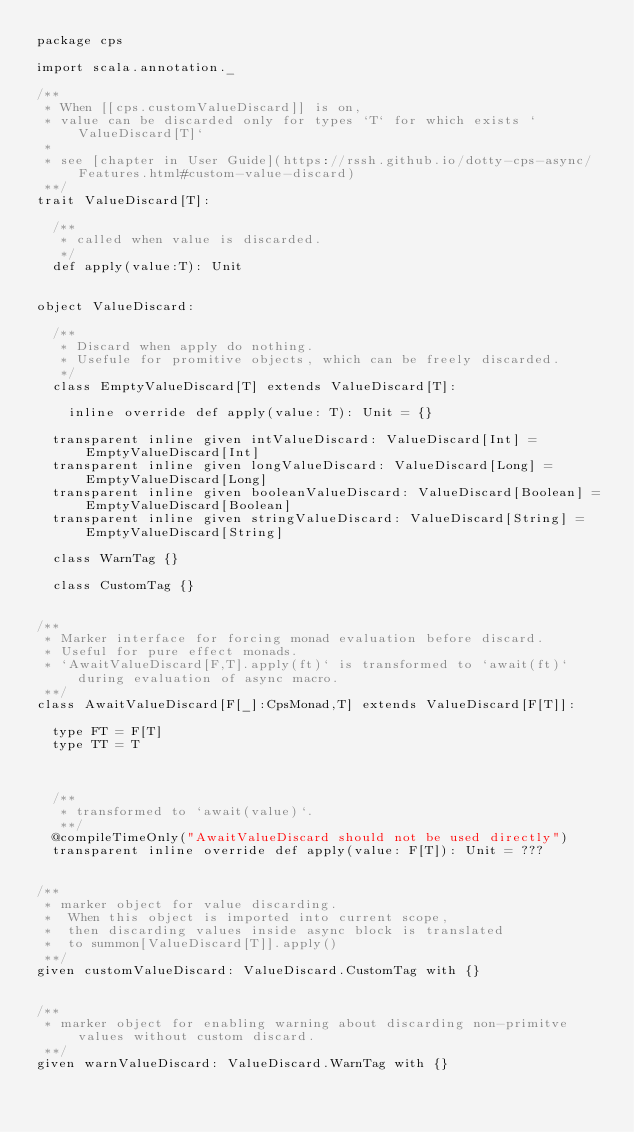Convert code to text. <code><loc_0><loc_0><loc_500><loc_500><_Scala_>package cps

import scala.annotation._

/**
 * When [[cps.customValueDiscard]] is on,
 * value can be discarded only for types `T` for which exists `ValueDiscard[T]`
 *
 * see [chapter in User Guide](https://rssh.github.io/dotty-cps-async/Features.html#custom-value-discard)
 **/
trait ValueDiscard[T]:

  /**
   * called when value is discarded. 
   */
  def apply(value:T): Unit


object ValueDiscard:

  /**
   * Discard when apply do nothing.
   * Usefule for promitive objects, which can be freely discarded.
   */
  class EmptyValueDiscard[T] extends ValueDiscard[T]:

    inline override def apply(value: T): Unit = {}

  transparent inline given intValueDiscard: ValueDiscard[Int] = EmptyValueDiscard[Int]
  transparent inline given longValueDiscard: ValueDiscard[Long] = EmptyValueDiscard[Long]
  transparent inline given booleanValueDiscard: ValueDiscard[Boolean] = EmptyValueDiscard[Boolean]
  transparent inline given stringValueDiscard: ValueDiscard[String] = EmptyValueDiscard[String]

  class WarnTag {}

  class CustomTag {}


/**
 * Marker interface for forcing monad evaluation before discard.
 * Useful for pure effect monads. 
 * `AwaitValueDiscard[F,T].apply(ft)` is transformed to `await(ft)` during evaluation of async macro.
 **/
class AwaitValueDiscard[F[_]:CpsMonad,T] extends ValueDiscard[F[T]]:

  type FT = F[T]
  type TT = T



  /**
   * transformed to `await(value)`.
   **/
  @compileTimeOnly("AwaitValueDiscard should not be used directly")
  transparent inline override def apply(value: F[T]): Unit = ???


/**
 * marker object for value discarding.
 *  When this object is imported into current scope,
 *  then discarding values inside async block is translated
 *  to summon[ValueDiscard[T]].apply()
 **/
given customValueDiscard: ValueDiscard.CustomTag with {}


/**
 * marker object for enabling warning about discarding non-primitve values without custom discard.
 **/
given warnValueDiscard: ValueDiscard.WarnTag with {}

</code> 